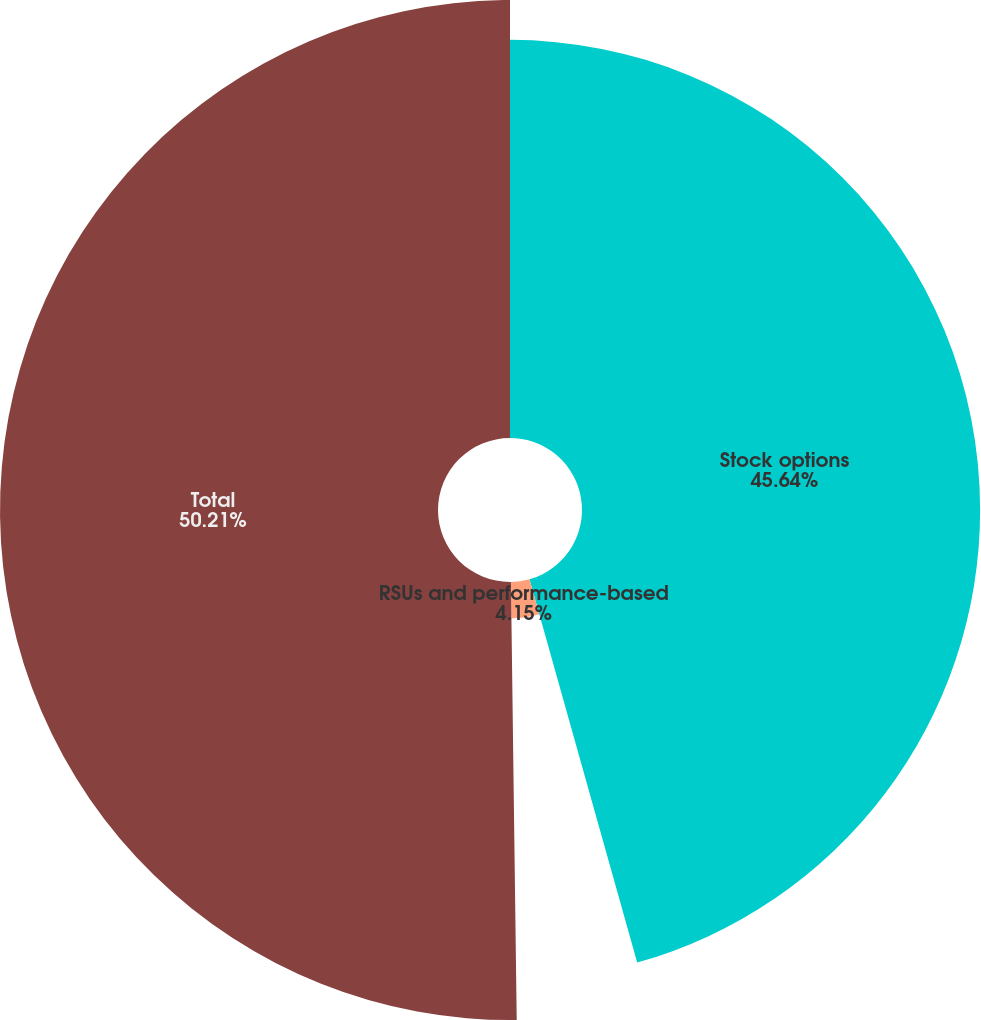Convert chart. <chart><loc_0><loc_0><loc_500><loc_500><pie_chart><fcel>Stock options<fcel>RSUs and performance-based<fcel>Total<nl><fcel>45.64%<fcel>4.15%<fcel>50.21%<nl></chart> 